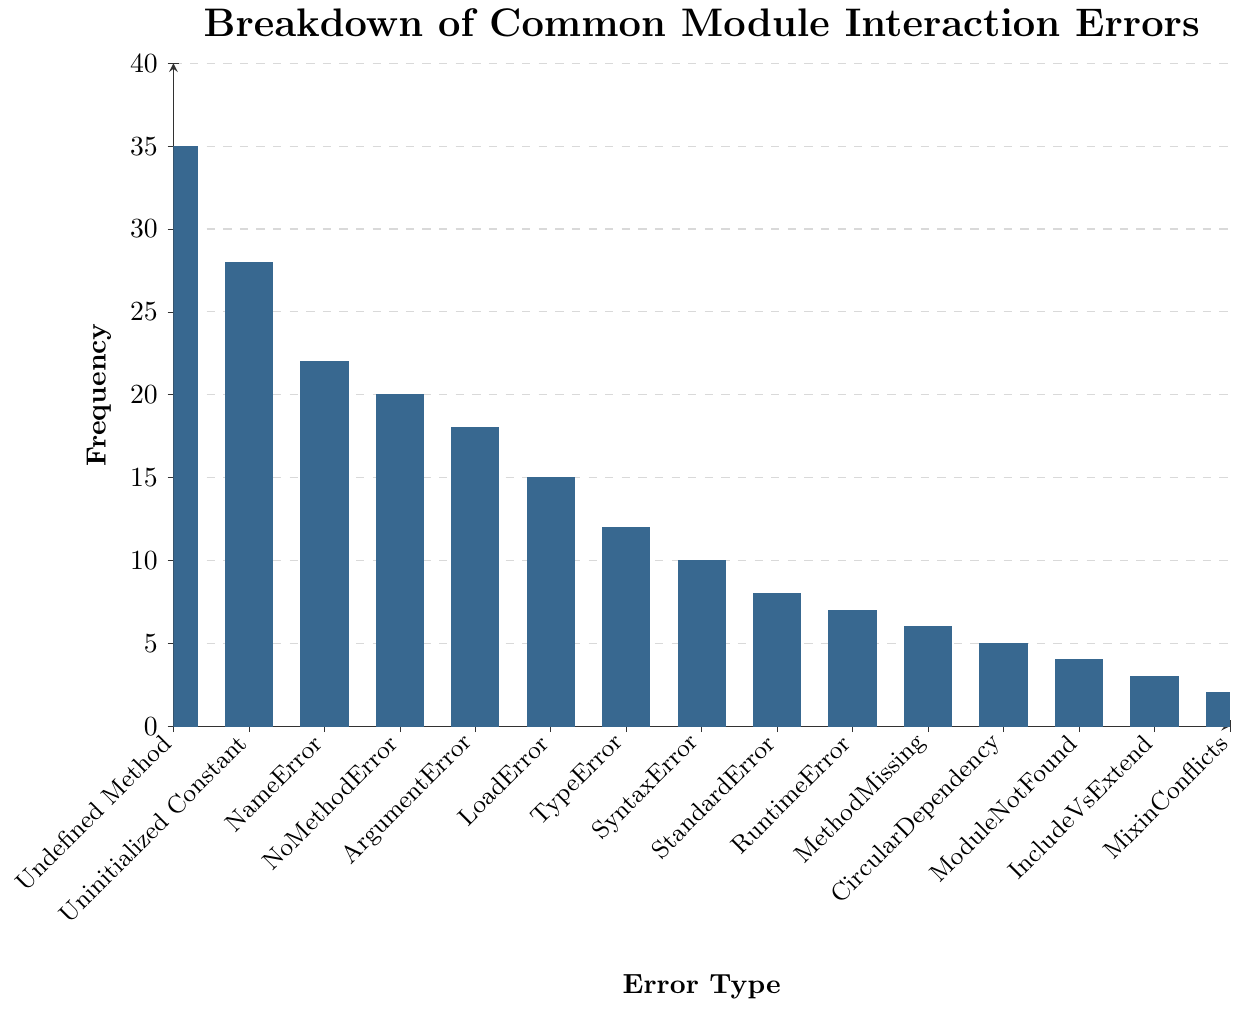What is the most frequent error type observed? The bar chart's highest bar indicates the most frequent error type. In the chart, the "Undefined Method" error has the highest bar.
Answer: Undefined Method What's the difference in frequency between Undefined Method errors and ArgumentError errors? The frequency of Undefined Method errors is 35, and the frequency of ArgumentError errors is 18. The difference is calculated as 35 - 18.
Answer: 17 Which error type has a frequency closest to 20? By examining the height of the bars, the NoMethodError has a frequency of 20, which matches the closest.
Answer: NoMethodError How many errors have a frequency higher than 15? Errors with frequencies higher than 15 are: Undefined Method (35), Uninitialized Constant (28), NameError (22), NoMethodError (20), and ArgumentError (18). Count these errors.
Answer: 5 What is the sum of the frequencies of CircularDependency and IncludeVsExtend errors? The frequency of CircularDependency errors is 5, and IncludeVsExtend errors is 3. Add 5 + 3 to find the sum.
Answer: 8 How does the frequency of LoadError compare to the frequency of TypeError? The frequency of LoadError is 15 and the frequency of TypeError is 12. Compare these two values.
Answer: LoadError is greater than TypeError What is the average frequency of the three most frequent errors? The frequencies of the three most frequent errors are Undefined Method (35), Uninitialized Constant (28), and NameError (22). Average is calculated as (35 + 28 + 22) / 3.
Answer: 28.33 Which error has the lowest frequency? By examining the height of the bars, the MixinConflicts error, with the shortest bar, has the lowest frequency of 2.
Answer: MixinConflicts What is the total frequency of errors with a frequency less than 10? Errors with frequencies less than 10 are: StandardError (8), RuntimeError (7), MethodMissing (6), CircularDependency (5), ModuleNotFound (4), IncludeVsExtend (3), MixinConflicts (2). Sum these frequencies: 8 + 7 + 6 + 5 + 4 + 3 + 2.
Answer: 35 